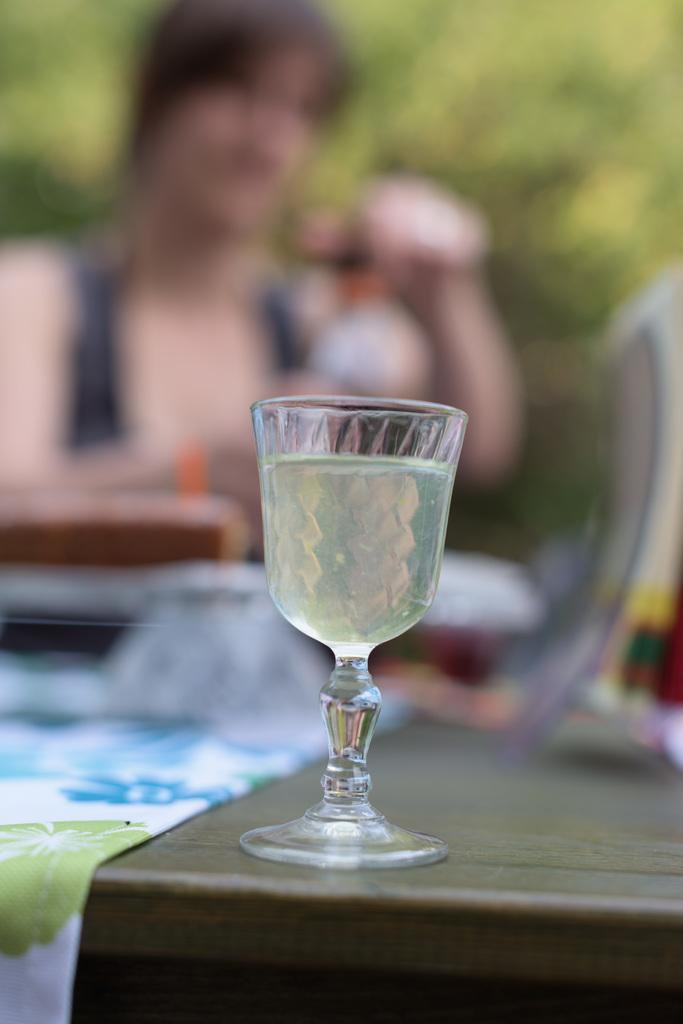What is contained in the glass that is visible in the image? There is liquid in a glass in the image. What is on the table in the image? There is a cloth on the table in the image. Can you describe the person in the background of the image? There is a person in the background of the image, but no specific details are provided. What else can be seen in the background of the image? There are objects in the background of the image. How would you describe the background of the image? The background is blurry. What type of muscle is being exercised by the person in the image? There is no person exercising a muscle in the image; the person is simply in the background. What type of stew is being prepared in the image? There is no stew or cooking activity present in the image. How many cats can be seen in the image? There are no cats present in the image. 